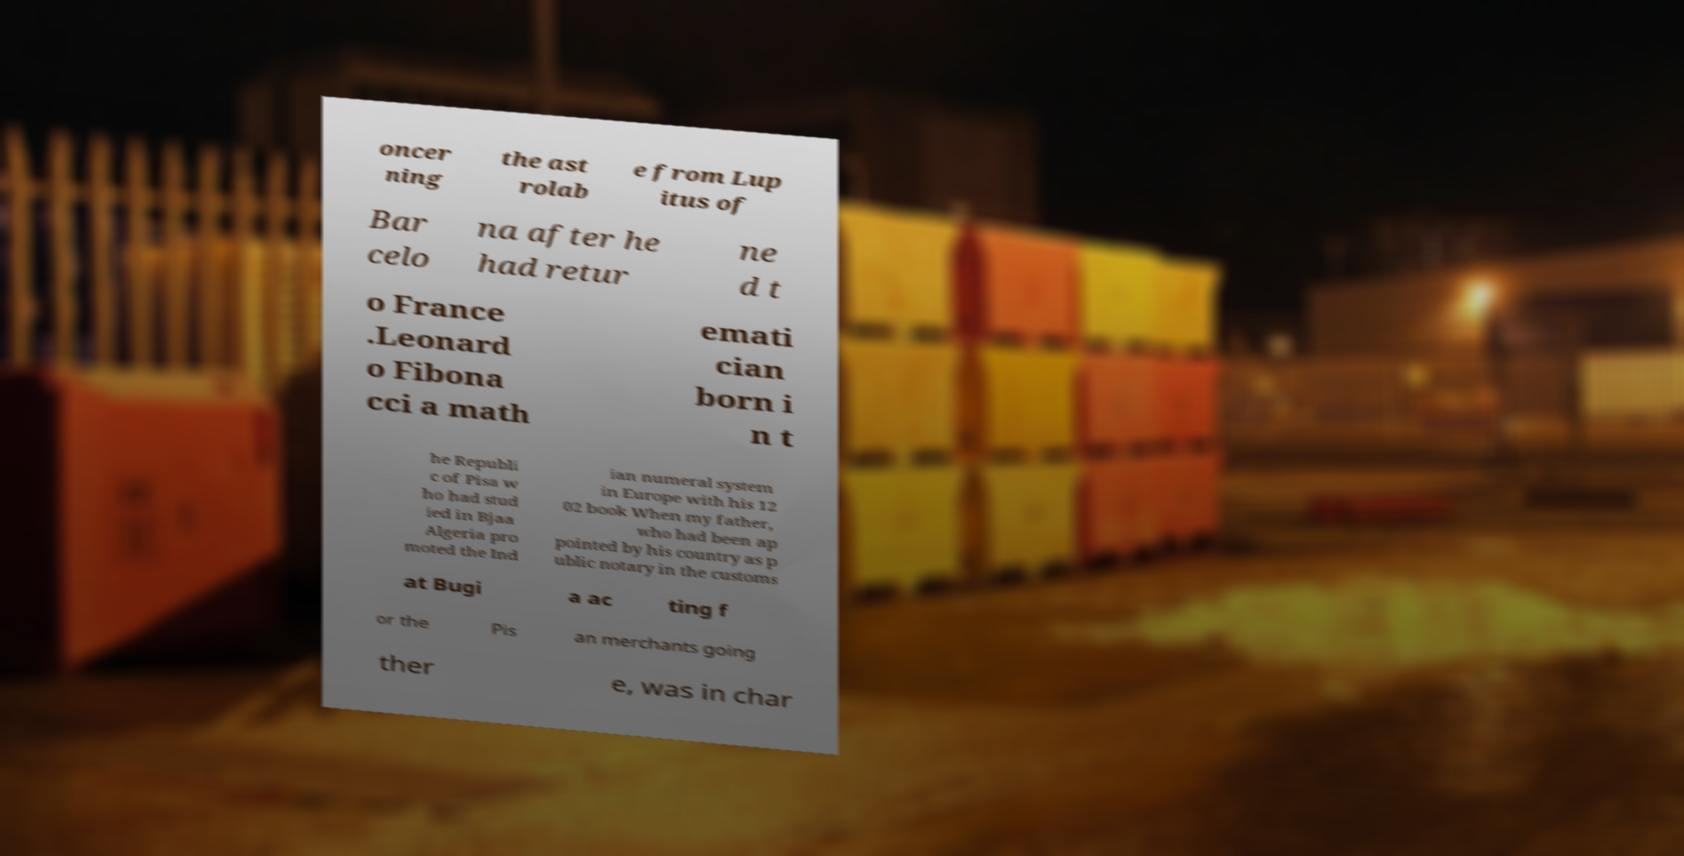Can you read and provide the text displayed in the image?This photo seems to have some interesting text. Can you extract and type it out for me? oncer ning the ast rolab e from Lup itus of Bar celo na after he had retur ne d t o France .Leonard o Fibona cci a math emati cian born i n t he Republi c of Pisa w ho had stud ied in Bjaa Algeria pro moted the Ind ian numeral system in Europe with his 12 02 book When my father, who had been ap pointed by his country as p ublic notary in the customs at Bugi a ac ting f or the Pis an merchants going ther e, was in char 